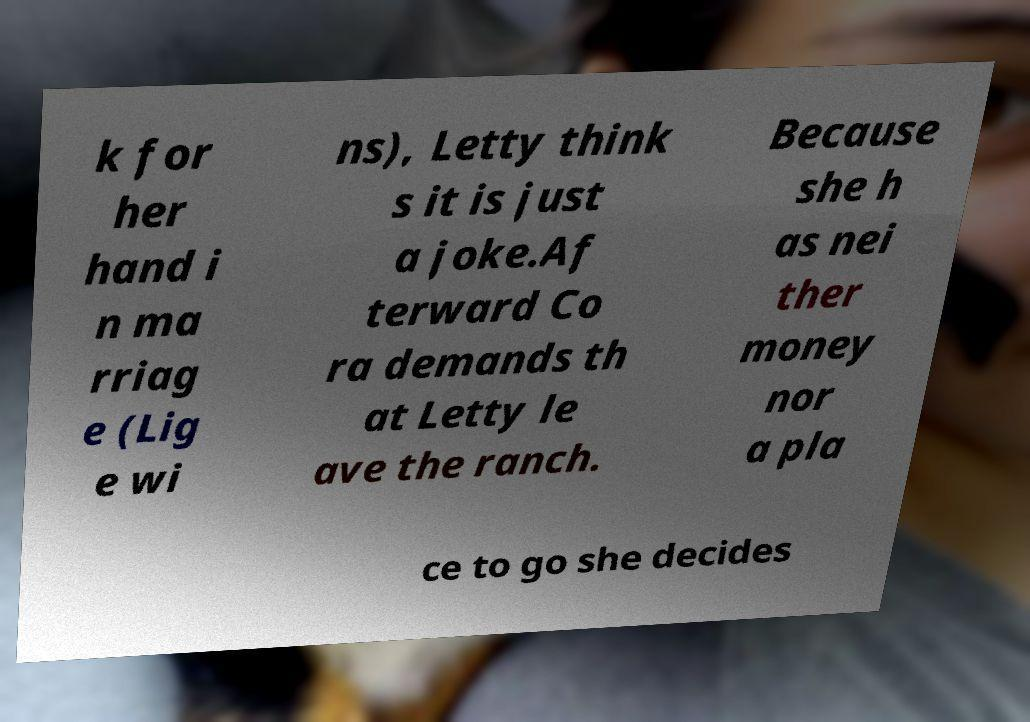For documentation purposes, I need the text within this image transcribed. Could you provide that? k for her hand i n ma rriag e (Lig e wi ns), Letty think s it is just a joke.Af terward Co ra demands th at Letty le ave the ranch. Because she h as nei ther money nor a pla ce to go she decides 